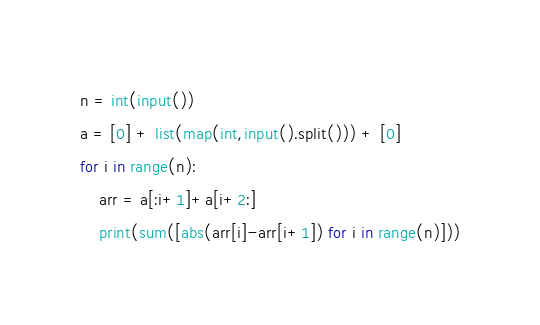Convert code to text. <code><loc_0><loc_0><loc_500><loc_500><_Python_>n = int(input())
a = [0] + list(map(int,input().split())) + [0]
for i in range(n):
    arr = a[:i+1]+a[i+2:]
    print(sum([abs(arr[i]-arr[i+1]) for i in range(n)]))</code> 